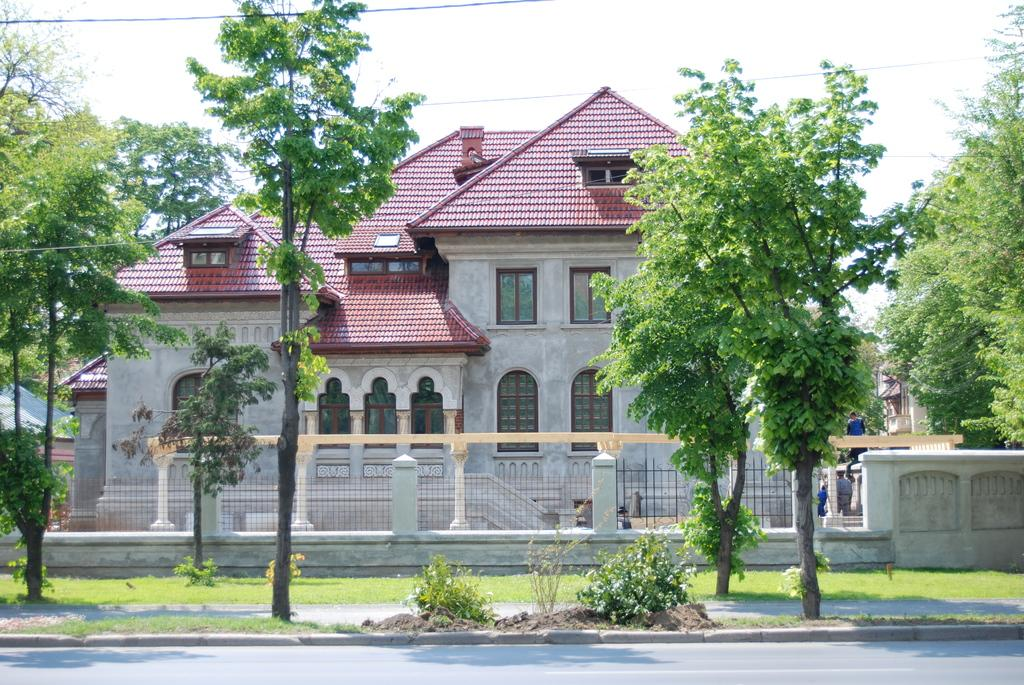What type of vegetation can be seen in the image? There are trees, plants, and grass visible in the image. What type of structures are present in the image? There are houses in the image. What man-made objects can be seen in the image? Cables and a road are present in the image. Are there any living beings in the image? Yes, there are people in the image. What part of the natural environment is visible in the image? The sky is visible in the image. Can you tell me where the kettle is located in the image? There is no kettle present in the image. What sense is being used by the people in the image? The provided facts do not give information about the senses being used by the people in the image. 